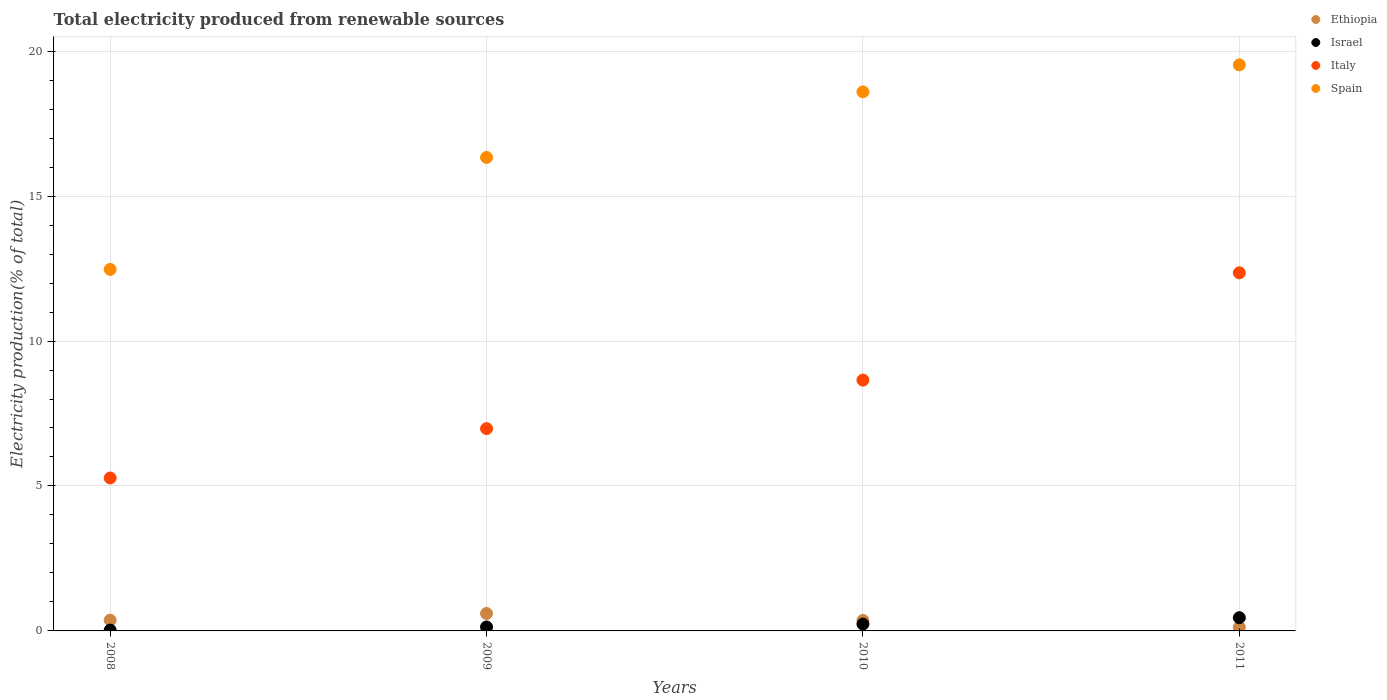Is the number of dotlines equal to the number of legend labels?
Make the answer very short. Yes. What is the total electricity produced in Italy in 2009?
Ensure brevity in your answer.  6.98. Across all years, what is the maximum total electricity produced in Italy?
Offer a terse response. 12.35. Across all years, what is the minimum total electricity produced in Spain?
Offer a terse response. 12.47. What is the total total electricity produced in Spain in the graph?
Provide a short and direct response. 66.92. What is the difference between the total electricity produced in Spain in 2008 and that in 2011?
Provide a succinct answer. -7.06. What is the difference between the total electricity produced in Ethiopia in 2010 and the total electricity produced in Israel in 2008?
Your response must be concise. 0.33. What is the average total electricity produced in Italy per year?
Your answer should be very brief. 8.31. In the year 2010, what is the difference between the total electricity produced in Spain and total electricity produced in Ethiopia?
Offer a terse response. 18.23. What is the ratio of the total electricity produced in Ethiopia in 2009 to that in 2010?
Your answer should be compact. 1.66. Is the total electricity produced in Ethiopia in 2008 less than that in 2010?
Provide a succinct answer. No. Is the difference between the total electricity produced in Spain in 2009 and 2011 greater than the difference between the total electricity produced in Ethiopia in 2009 and 2011?
Give a very brief answer. No. What is the difference between the highest and the second highest total electricity produced in Spain?
Make the answer very short. 0.93. What is the difference between the highest and the lowest total electricity produced in Italy?
Provide a succinct answer. 7.08. In how many years, is the total electricity produced in Ethiopia greater than the average total electricity produced in Ethiopia taken over all years?
Your response must be concise. 2. Is the sum of the total electricity produced in Italy in 2009 and 2010 greater than the maximum total electricity produced in Spain across all years?
Your response must be concise. No. Does the total electricity produced in Italy monotonically increase over the years?
Your answer should be very brief. Yes. Is the total electricity produced in Ethiopia strictly greater than the total electricity produced in Spain over the years?
Provide a short and direct response. No. How many dotlines are there?
Offer a very short reply. 4. How many years are there in the graph?
Make the answer very short. 4. Are the values on the major ticks of Y-axis written in scientific E-notation?
Provide a short and direct response. No. Where does the legend appear in the graph?
Offer a terse response. Top right. How many legend labels are there?
Provide a short and direct response. 4. How are the legend labels stacked?
Provide a succinct answer. Vertical. What is the title of the graph?
Make the answer very short. Total electricity produced from renewable sources. Does "Romania" appear as one of the legend labels in the graph?
Offer a very short reply. No. What is the label or title of the X-axis?
Your answer should be compact. Years. What is the Electricity production(% of total) in Ethiopia in 2008?
Keep it short and to the point. 0.37. What is the Electricity production(% of total) in Israel in 2008?
Keep it short and to the point. 0.03. What is the Electricity production(% of total) of Italy in 2008?
Offer a very short reply. 5.28. What is the Electricity production(% of total) of Spain in 2008?
Give a very brief answer. 12.47. What is the Electricity production(% of total) in Ethiopia in 2009?
Offer a very short reply. 0.6. What is the Electricity production(% of total) in Israel in 2009?
Your answer should be very brief. 0.14. What is the Electricity production(% of total) in Italy in 2009?
Offer a very short reply. 6.98. What is the Electricity production(% of total) in Spain in 2009?
Ensure brevity in your answer.  16.33. What is the Electricity production(% of total) in Ethiopia in 2010?
Keep it short and to the point. 0.36. What is the Electricity production(% of total) of Israel in 2010?
Provide a succinct answer. 0.24. What is the Electricity production(% of total) of Italy in 2010?
Your response must be concise. 8.65. What is the Electricity production(% of total) of Spain in 2010?
Ensure brevity in your answer.  18.59. What is the Electricity production(% of total) in Ethiopia in 2011?
Provide a succinct answer. 0.13. What is the Electricity production(% of total) of Israel in 2011?
Provide a short and direct response. 0.46. What is the Electricity production(% of total) of Italy in 2011?
Keep it short and to the point. 12.35. What is the Electricity production(% of total) in Spain in 2011?
Ensure brevity in your answer.  19.53. Across all years, what is the maximum Electricity production(% of total) in Ethiopia?
Provide a short and direct response. 0.6. Across all years, what is the maximum Electricity production(% of total) of Israel?
Offer a very short reply. 0.46. Across all years, what is the maximum Electricity production(% of total) in Italy?
Provide a succinct answer. 12.35. Across all years, what is the maximum Electricity production(% of total) of Spain?
Offer a very short reply. 19.53. Across all years, what is the minimum Electricity production(% of total) in Ethiopia?
Your answer should be very brief. 0.13. Across all years, what is the minimum Electricity production(% of total) of Israel?
Offer a terse response. 0.03. Across all years, what is the minimum Electricity production(% of total) of Italy?
Your answer should be compact. 5.28. Across all years, what is the minimum Electricity production(% of total) in Spain?
Keep it short and to the point. 12.47. What is the total Electricity production(% of total) of Ethiopia in the graph?
Your answer should be compact. 1.46. What is the total Electricity production(% of total) of Israel in the graph?
Keep it short and to the point. 0.86. What is the total Electricity production(% of total) in Italy in the graph?
Your answer should be compact. 33.26. What is the total Electricity production(% of total) in Spain in the graph?
Your answer should be very brief. 66.92. What is the difference between the Electricity production(% of total) of Ethiopia in 2008 and that in 2009?
Your answer should be compact. -0.23. What is the difference between the Electricity production(% of total) in Israel in 2008 and that in 2009?
Your response must be concise. -0.11. What is the difference between the Electricity production(% of total) of Italy in 2008 and that in 2009?
Provide a succinct answer. -1.7. What is the difference between the Electricity production(% of total) of Spain in 2008 and that in 2009?
Your response must be concise. -3.86. What is the difference between the Electricity production(% of total) in Ethiopia in 2008 and that in 2010?
Keep it short and to the point. 0.01. What is the difference between the Electricity production(% of total) of Israel in 2008 and that in 2010?
Make the answer very short. -0.21. What is the difference between the Electricity production(% of total) in Italy in 2008 and that in 2010?
Provide a succinct answer. -3.38. What is the difference between the Electricity production(% of total) in Spain in 2008 and that in 2010?
Offer a very short reply. -6.12. What is the difference between the Electricity production(% of total) in Ethiopia in 2008 and that in 2011?
Offer a very short reply. 0.24. What is the difference between the Electricity production(% of total) in Israel in 2008 and that in 2011?
Keep it short and to the point. -0.43. What is the difference between the Electricity production(% of total) of Italy in 2008 and that in 2011?
Provide a short and direct response. -7.08. What is the difference between the Electricity production(% of total) of Spain in 2008 and that in 2011?
Keep it short and to the point. -7.06. What is the difference between the Electricity production(% of total) of Ethiopia in 2009 and that in 2010?
Make the answer very short. 0.24. What is the difference between the Electricity production(% of total) in Israel in 2009 and that in 2010?
Ensure brevity in your answer.  -0.1. What is the difference between the Electricity production(% of total) in Italy in 2009 and that in 2010?
Offer a very short reply. -1.67. What is the difference between the Electricity production(% of total) in Spain in 2009 and that in 2010?
Provide a succinct answer. -2.26. What is the difference between the Electricity production(% of total) of Ethiopia in 2009 and that in 2011?
Offer a terse response. 0.47. What is the difference between the Electricity production(% of total) in Israel in 2009 and that in 2011?
Your answer should be compact. -0.32. What is the difference between the Electricity production(% of total) in Italy in 2009 and that in 2011?
Your response must be concise. -5.38. What is the difference between the Electricity production(% of total) in Spain in 2009 and that in 2011?
Your answer should be compact. -3.19. What is the difference between the Electricity production(% of total) of Ethiopia in 2010 and that in 2011?
Your answer should be very brief. 0.23. What is the difference between the Electricity production(% of total) in Israel in 2010 and that in 2011?
Offer a terse response. -0.22. What is the difference between the Electricity production(% of total) of Italy in 2010 and that in 2011?
Your answer should be very brief. -3.7. What is the difference between the Electricity production(% of total) in Spain in 2010 and that in 2011?
Make the answer very short. -0.93. What is the difference between the Electricity production(% of total) in Ethiopia in 2008 and the Electricity production(% of total) in Israel in 2009?
Make the answer very short. 0.23. What is the difference between the Electricity production(% of total) in Ethiopia in 2008 and the Electricity production(% of total) in Italy in 2009?
Provide a succinct answer. -6.61. What is the difference between the Electricity production(% of total) of Ethiopia in 2008 and the Electricity production(% of total) of Spain in 2009?
Offer a terse response. -15.96. What is the difference between the Electricity production(% of total) in Israel in 2008 and the Electricity production(% of total) in Italy in 2009?
Provide a short and direct response. -6.95. What is the difference between the Electricity production(% of total) in Israel in 2008 and the Electricity production(% of total) in Spain in 2009?
Offer a very short reply. -16.3. What is the difference between the Electricity production(% of total) of Italy in 2008 and the Electricity production(% of total) of Spain in 2009?
Provide a short and direct response. -11.06. What is the difference between the Electricity production(% of total) in Ethiopia in 2008 and the Electricity production(% of total) in Israel in 2010?
Offer a terse response. 0.13. What is the difference between the Electricity production(% of total) in Ethiopia in 2008 and the Electricity production(% of total) in Italy in 2010?
Your response must be concise. -8.28. What is the difference between the Electricity production(% of total) of Ethiopia in 2008 and the Electricity production(% of total) of Spain in 2010?
Give a very brief answer. -18.22. What is the difference between the Electricity production(% of total) of Israel in 2008 and the Electricity production(% of total) of Italy in 2010?
Make the answer very short. -8.62. What is the difference between the Electricity production(% of total) of Israel in 2008 and the Electricity production(% of total) of Spain in 2010?
Your response must be concise. -18.57. What is the difference between the Electricity production(% of total) of Italy in 2008 and the Electricity production(% of total) of Spain in 2010?
Make the answer very short. -13.32. What is the difference between the Electricity production(% of total) of Ethiopia in 2008 and the Electricity production(% of total) of Israel in 2011?
Offer a terse response. -0.09. What is the difference between the Electricity production(% of total) of Ethiopia in 2008 and the Electricity production(% of total) of Italy in 2011?
Your answer should be very brief. -11.98. What is the difference between the Electricity production(% of total) of Ethiopia in 2008 and the Electricity production(% of total) of Spain in 2011?
Your answer should be compact. -19.16. What is the difference between the Electricity production(% of total) of Israel in 2008 and the Electricity production(% of total) of Italy in 2011?
Offer a terse response. -12.32. What is the difference between the Electricity production(% of total) in Israel in 2008 and the Electricity production(% of total) in Spain in 2011?
Make the answer very short. -19.5. What is the difference between the Electricity production(% of total) of Italy in 2008 and the Electricity production(% of total) of Spain in 2011?
Offer a terse response. -14.25. What is the difference between the Electricity production(% of total) of Ethiopia in 2009 and the Electricity production(% of total) of Israel in 2010?
Your answer should be compact. 0.36. What is the difference between the Electricity production(% of total) in Ethiopia in 2009 and the Electricity production(% of total) in Italy in 2010?
Your answer should be very brief. -8.05. What is the difference between the Electricity production(% of total) of Ethiopia in 2009 and the Electricity production(% of total) of Spain in 2010?
Your response must be concise. -17.99. What is the difference between the Electricity production(% of total) of Israel in 2009 and the Electricity production(% of total) of Italy in 2010?
Keep it short and to the point. -8.52. What is the difference between the Electricity production(% of total) in Israel in 2009 and the Electricity production(% of total) in Spain in 2010?
Give a very brief answer. -18.46. What is the difference between the Electricity production(% of total) in Italy in 2009 and the Electricity production(% of total) in Spain in 2010?
Offer a terse response. -11.62. What is the difference between the Electricity production(% of total) of Ethiopia in 2009 and the Electricity production(% of total) of Israel in 2011?
Provide a short and direct response. 0.15. What is the difference between the Electricity production(% of total) of Ethiopia in 2009 and the Electricity production(% of total) of Italy in 2011?
Provide a short and direct response. -11.75. What is the difference between the Electricity production(% of total) of Ethiopia in 2009 and the Electricity production(% of total) of Spain in 2011?
Provide a succinct answer. -18.93. What is the difference between the Electricity production(% of total) of Israel in 2009 and the Electricity production(% of total) of Italy in 2011?
Make the answer very short. -12.22. What is the difference between the Electricity production(% of total) in Israel in 2009 and the Electricity production(% of total) in Spain in 2011?
Make the answer very short. -19.39. What is the difference between the Electricity production(% of total) in Italy in 2009 and the Electricity production(% of total) in Spain in 2011?
Provide a succinct answer. -12.55. What is the difference between the Electricity production(% of total) in Ethiopia in 2010 and the Electricity production(% of total) in Israel in 2011?
Your response must be concise. -0.09. What is the difference between the Electricity production(% of total) of Ethiopia in 2010 and the Electricity production(% of total) of Italy in 2011?
Your answer should be very brief. -11.99. What is the difference between the Electricity production(% of total) in Ethiopia in 2010 and the Electricity production(% of total) in Spain in 2011?
Give a very brief answer. -19.17. What is the difference between the Electricity production(% of total) in Israel in 2010 and the Electricity production(% of total) in Italy in 2011?
Keep it short and to the point. -12.12. What is the difference between the Electricity production(% of total) in Israel in 2010 and the Electricity production(% of total) in Spain in 2011?
Give a very brief answer. -19.29. What is the difference between the Electricity production(% of total) in Italy in 2010 and the Electricity production(% of total) in Spain in 2011?
Your answer should be very brief. -10.87. What is the average Electricity production(% of total) in Ethiopia per year?
Your answer should be compact. 0.36. What is the average Electricity production(% of total) of Israel per year?
Offer a very short reply. 0.21. What is the average Electricity production(% of total) in Italy per year?
Give a very brief answer. 8.31. What is the average Electricity production(% of total) of Spain per year?
Your answer should be very brief. 16.73. In the year 2008, what is the difference between the Electricity production(% of total) in Ethiopia and Electricity production(% of total) in Israel?
Provide a succinct answer. 0.34. In the year 2008, what is the difference between the Electricity production(% of total) of Ethiopia and Electricity production(% of total) of Italy?
Offer a terse response. -4.9. In the year 2008, what is the difference between the Electricity production(% of total) in Ethiopia and Electricity production(% of total) in Spain?
Provide a short and direct response. -12.1. In the year 2008, what is the difference between the Electricity production(% of total) in Israel and Electricity production(% of total) in Italy?
Your answer should be very brief. -5.25. In the year 2008, what is the difference between the Electricity production(% of total) in Israel and Electricity production(% of total) in Spain?
Offer a terse response. -12.44. In the year 2008, what is the difference between the Electricity production(% of total) in Italy and Electricity production(% of total) in Spain?
Give a very brief answer. -7.19. In the year 2009, what is the difference between the Electricity production(% of total) of Ethiopia and Electricity production(% of total) of Israel?
Make the answer very short. 0.46. In the year 2009, what is the difference between the Electricity production(% of total) of Ethiopia and Electricity production(% of total) of Italy?
Ensure brevity in your answer.  -6.38. In the year 2009, what is the difference between the Electricity production(% of total) of Ethiopia and Electricity production(% of total) of Spain?
Offer a terse response. -15.73. In the year 2009, what is the difference between the Electricity production(% of total) in Israel and Electricity production(% of total) in Italy?
Provide a succinct answer. -6.84. In the year 2009, what is the difference between the Electricity production(% of total) of Israel and Electricity production(% of total) of Spain?
Offer a terse response. -16.2. In the year 2009, what is the difference between the Electricity production(% of total) of Italy and Electricity production(% of total) of Spain?
Ensure brevity in your answer.  -9.36. In the year 2010, what is the difference between the Electricity production(% of total) in Ethiopia and Electricity production(% of total) in Israel?
Offer a very short reply. 0.12. In the year 2010, what is the difference between the Electricity production(% of total) in Ethiopia and Electricity production(% of total) in Italy?
Keep it short and to the point. -8.29. In the year 2010, what is the difference between the Electricity production(% of total) in Ethiopia and Electricity production(% of total) in Spain?
Keep it short and to the point. -18.23. In the year 2010, what is the difference between the Electricity production(% of total) in Israel and Electricity production(% of total) in Italy?
Provide a short and direct response. -8.41. In the year 2010, what is the difference between the Electricity production(% of total) of Israel and Electricity production(% of total) of Spain?
Give a very brief answer. -18.36. In the year 2010, what is the difference between the Electricity production(% of total) in Italy and Electricity production(% of total) in Spain?
Your answer should be very brief. -9.94. In the year 2011, what is the difference between the Electricity production(% of total) of Ethiopia and Electricity production(% of total) of Israel?
Ensure brevity in your answer.  -0.33. In the year 2011, what is the difference between the Electricity production(% of total) of Ethiopia and Electricity production(% of total) of Italy?
Provide a short and direct response. -12.23. In the year 2011, what is the difference between the Electricity production(% of total) in Ethiopia and Electricity production(% of total) in Spain?
Keep it short and to the point. -19.4. In the year 2011, what is the difference between the Electricity production(% of total) in Israel and Electricity production(% of total) in Italy?
Your response must be concise. -11.9. In the year 2011, what is the difference between the Electricity production(% of total) of Israel and Electricity production(% of total) of Spain?
Give a very brief answer. -19.07. In the year 2011, what is the difference between the Electricity production(% of total) of Italy and Electricity production(% of total) of Spain?
Keep it short and to the point. -7.17. What is the ratio of the Electricity production(% of total) in Ethiopia in 2008 to that in 2009?
Your response must be concise. 0.62. What is the ratio of the Electricity production(% of total) in Israel in 2008 to that in 2009?
Offer a very short reply. 0.21. What is the ratio of the Electricity production(% of total) in Italy in 2008 to that in 2009?
Offer a very short reply. 0.76. What is the ratio of the Electricity production(% of total) of Spain in 2008 to that in 2009?
Ensure brevity in your answer.  0.76. What is the ratio of the Electricity production(% of total) of Ethiopia in 2008 to that in 2010?
Make the answer very short. 1.03. What is the ratio of the Electricity production(% of total) in Israel in 2008 to that in 2010?
Provide a succinct answer. 0.12. What is the ratio of the Electricity production(% of total) of Italy in 2008 to that in 2010?
Your response must be concise. 0.61. What is the ratio of the Electricity production(% of total) of Spain in 2008 to that in 2010?
Offer a terse response. 0.67. What is the ratio of the Electricity production(% of total) in Ethiopia in 2008 to that in 2011?
Keep it short and to the point. 2.92. What is the ratio of the Electricity production(% of total) in Israel in 2008 to that in 2011?
Ensure brevity in your answer.  0.06. What is the ratio of the Electricity production(% of total) of Italy in 2008 to that in 2011?
Your answer should be very brief. 0.43. What is the ratio of the Electricity production(% of total) in Spain in 2008 to that in 2011?
Keep it short and to the point. 0.64. What is the ratio of the Electricity production(% of total) in Ethiopia in 2009 to that in 2010?
Your answer should be very brief. 1.66. What is the ratio of the Electricity production(% of total) of Israel in 2009 to that in 2010?
Your answer should be very brief. 0.57. What is the ratio of the Electricity production(% of total) of Italy in 2009 to that in 2010?
Make the answer very short. 0.81. What is the ratio of the Electricity production(% of total) of Spain in 2009 to that in 2010?
Offer a very short reply. 0.88. What is the ratio of the Electricity production(% of total) of Ethiopia in 2009 to that in 2011?
Your answer should be compact. 4.74. What is the ratio of the Electricity production(% of total) in Israel in 2009 to that in 2011?
Provide a short and direct response. 0.3. What is the ratio of the Electricity production(% of total) of Italy in 2009 to that in 2011?
Your response must be concise. 0.56. What is the ratio of the Electricity production(% of total) in Spain in 2009 to that in 2011?
Provide a short and direct response. 0.84. What is the ratio of the Electricity production(% of total) in Ethiopia in 2010 to that in 2011?
Make the answer very short. 2.85. What is the ratio of the Electricity production(% of total) in Israel in 2010 to that in 2011?
Provide a succinct answer. 0.52. What is the ratio of the Electricity production(% of total) in Italy in 2010 to that in 2011?
Provide a short and direct response. 0.7. What is the ratio of the Electricity production(% of total) in Spain in 2010 to that in 2011?
Ensure brevity in your answer.  0.95. What is the difference between the highest and the second highest Electricity production(% of total) in Ethiopia?
Your answer should be compact. 0.23. What is the difference between the highest and the second highest Electricity production(% of total) in Israel?
Provide a short and direct response. 0.22. What is the difference between the highest and the second highest Electricity production(% of total) of Italy?
Offer a terse response. 3.7. What is the difference between the highest and the second highest Electricity production(% of total) in Spain?
Keep it short and to the point. 0.93. What is the difference between the highest and the lowest Electricity production(% of total) of Ethiopia?
Offer a terse response. 0.47. What is the difference between the highest and the lowest Electricity production(% of total) in Israel?
Offer a very short reply. 0.43. What is the difference between the highest and the lowest Electricity production(% of total) of Italy?
Offer a very short reply. 7.08. What is the difference between the highest and the lowest Electricity production(% of total) in Spain?
Offer a very short reply. 7.06. 